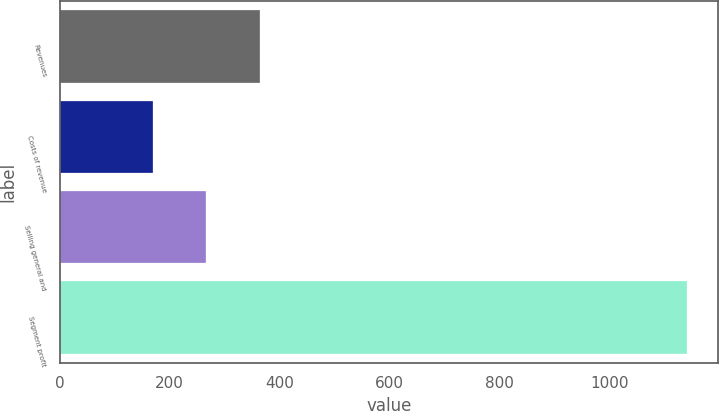Convert chart. <chart><loc_0><loc_0><loc_500><loc_500><bar_chart><fcel>Revenues<fcel>Costs of revenue<fcel>Selling general and<fcel>Segment profit<nl><fcel>364.02<fcel>169.5<fcel>266.76<fcel>1142.1<nl></chart> 